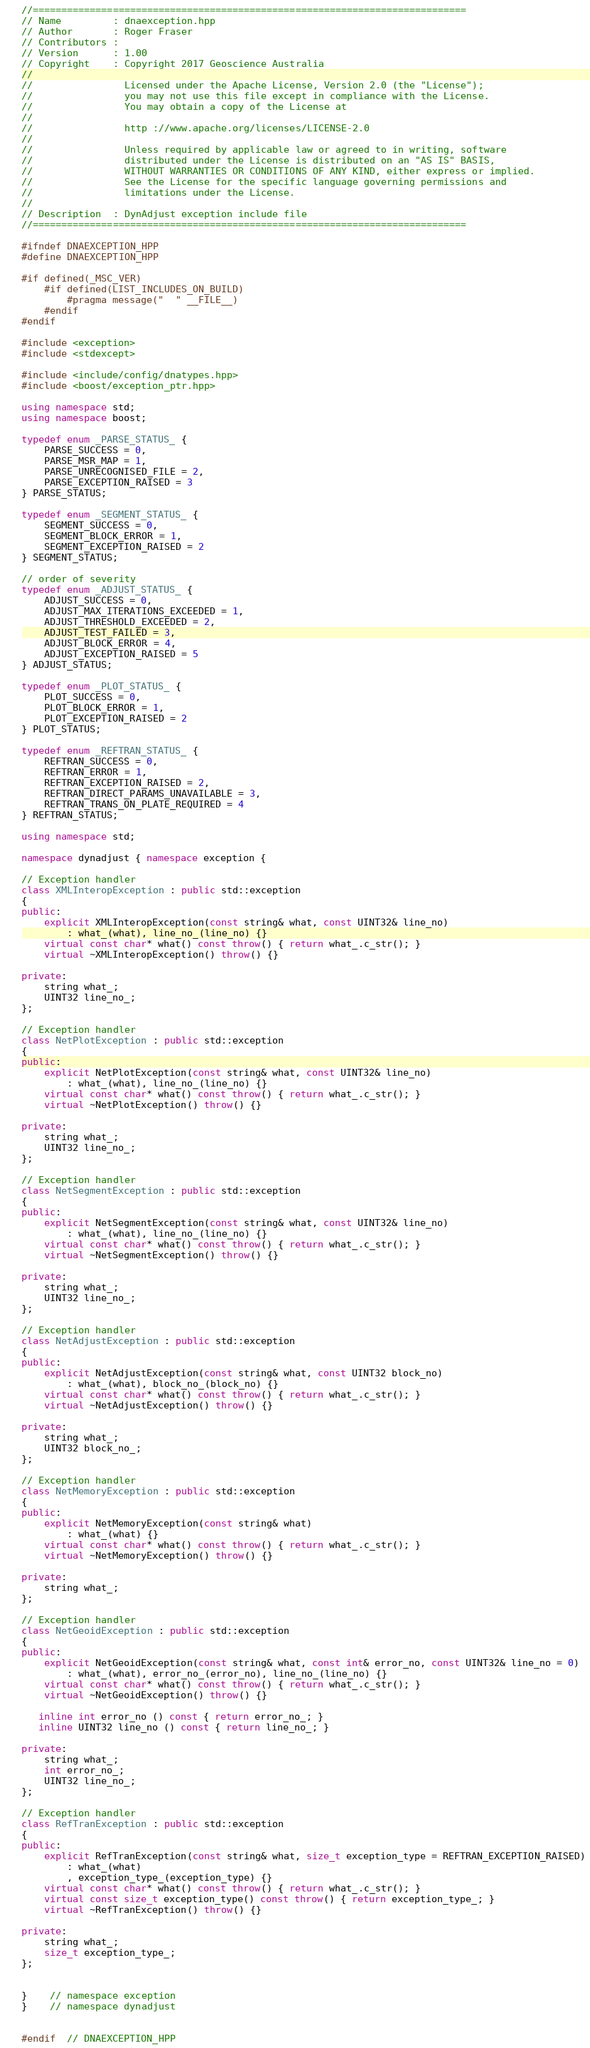<code> <loc_0><loc_0><loc_500><loc_500><_C++_>//============================================================================
// Name         : dnaexception.hpp
// Author       : Roger Fraser
// Contributors :
// Version      : 1.00
// Copyright    : Copyright 2017 Geoscience Australia
//
//                Licensed under the Apache License, Version 2.0 (the "License");
//                you may not use this file except in compliance with the License.
//                You may obtain a copy of the License at
//               
//                http ://www.apache.org/licenses/LICENSE-2.0
//               
//                Unless required by applicable law or agreed to in writing, software
//                distributed under the License is distributed on an "AS IS" BASIS,
//                WITHOUT WARRANTIES OR CONDITIONS OF ANY KIND, either express or implied.
//                See the License for the specific language governing permissions and
//                limitations under the License.
//
// Description  : DynAdjust exception include file
//============================================================================

#ifndef DNAEXCEPTION_HPP
#define DNAEXCEPTION_HPP

#if defined(_MSC_VER)
	#if defined(LIST_INCLUDES_ON_BUILD) 
		#pragma message("  " __FILE__) 
	#endif
#endif

#include <exception>
#include <stdexcept>

#include <include/config/dnatypes.hpp>
#include <boost/exception_ptr.hpp>

using namespace std;
using namespace boost;

typedef enum _PARSE_STATUS_ {
	PARSE_SUCCESS = 0,
	PARSE_MSR_MAP = 1,
	PARSE_UNRECOGNISED_FILE = 2,
	PARSE_EXCEPTION_RAISED = 3
} PARSE_STATUS;

typedef enum _SEGMENT_STATUS_ {
	SEGMENT_SUCCESS = 0,
	SEGMENT_BLOCK_ERROR = 1,
	SEGMENT_EXCEPTION_RAISED = 2
} SEGMENT_STATUS;

// order of severity
typedef enum _ADJUST_STATUS_ {
	ADJUST_SUCCESS = 0,
	ADJUST_MAX_ITERATIONS_EXCEEDED = 1,
	ADJUST_THRESHOLD_EXCEEDED = 2,
	ADJUST_TEST_FAILED = 3,
	ADJUST_BLOCK_ERROR = 4,
	ADJUST_EXCEPTION_RAISED = 5
} ADJUST_STATUS;

typedef enum _PLOT_STATUS_ {
	PLOT_SUCCESS = 0,
	PLOT_BLOCK_ERROR = 1,
	PLOT_EXCEPTION_RAISED = 2
} PLOT_STATUS;

typedef enum _REFTRAN_STATUS_ {
	REFTRAN_SUCCESS = 0,
	REFTRAN_ERROR = 1,
	REFTRAN_EXCEPTION_RAISED = 2,
	REFTRAN_DIRECT_PARAMS_UNAVAILABLE = 3,
	REFTRAN_TRANS_ON_PLATE_REQUIRED = 4
} REFTRAN_STATUS;

using namespace std;

namespace dynadjust { namespace exception {

// Exception handler
class XMLInteropException : public std::exception
{
public:
	explicit XMLInteropException(const string& what, const UINT32& line_no)
		: what_(what), line_no_(line_no) {}
	virtual const char* what() const throw() { return what_.c_str(); }
	virtual ~XMLInteropException() throw() {}

private:
	string what_;
	UINT32 line_no_;
};

// Exception handler
class NetPlotException : public std::exception
{
public:
	explicit NetPlotException(const string& what, const UINT32& line_no)
		: what_(what), line_no_(line_no) {}
	virtual const char* what() const throw() { return what_.c_str(); }
	virtual ~NetPlotException() throw() {}

private:
	string what_;
	UINT32 line_no_;
};

// Exception handler
class NetSegmentException : public std::exception
{
public:
	explicit NetSegmentException(const string& what, const UINT32& line_no)
		: what_(what), line_no_(line_no) {}
	virtual const char* what() const throw() { return what_.c_str(); }
	virtual ~NetSegmentException() throw() {}

private:
	string what_;
	UINT32 line_no_;
};

// Exception handler
class NetAdjustException : public std::exception
{
public:
	explicit NetAdjustException(const string& what, const UINT32 block_no)
		: what_(what), block_no_(block_no) {}
	virtual const char* what() const throw() { return what_.c_str(); }
	virtual ~NetAdjustException() throw() {}

private:
	string what_;
	UINT32 block_no_;
};

// Exception handler
class NetMemoryException : public std::exception
{
public:
	explicit NetMemoryException(const string& what)
		: what_(what) {}
	virtual const char* what() const throw() { return what_.c_str(); }
	virtual ~NetMemoryException() throw() {}

private:
	string what_;
};

// Exception handler
class NetGeoidException : public std::exception
{
public:
	explicit NetGeoidException(const string& what, const int& error_no, const UINT32& line_no = 0)
		: what_(what), error_no_(error_no), line_no_(line_no) {}
	virtual const char* what() const throw() { return what_.c_str(); }
	virtual ~NetGeoidException() throw() {}

   inline int error_no () const { return error_no_; }
   inline UINT32 line_no () const { return line_no_; }

private:
	string what_;
	int error_no_;
	UINT32 line_no_;
};

// Exception handler
class RefTranException : public std::exception
{
public:
	explicit RefTranException(const string& what, size_t exception_type = REFTRAN_EXCEPTION_RAISED)
		: what_(what)
		, exception_type_(exception_type) {}
	virtual const char* what() const throw() { return what_.c_str(); }
	virtual const size_t exception_type() const throw() { return exception_type_; }
	virtual ~RefTranException() throw() {}

private:
	string what_;
	size_t exception_type_;
};


}	// namespace exception
}	// namespace dynadjust


#endif  // DNAEXCEPTION_HPP
</code> 